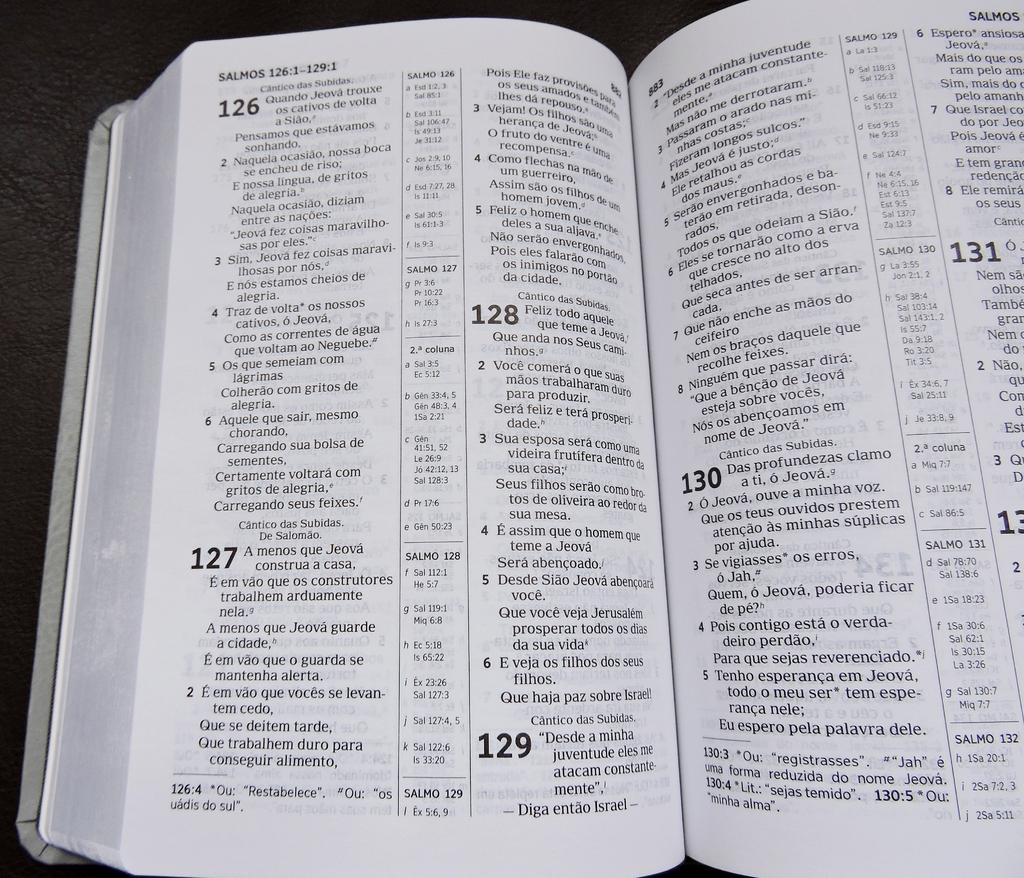<image>
Write a terse but informative summary of the picture. An open book with the pages written in spanish 